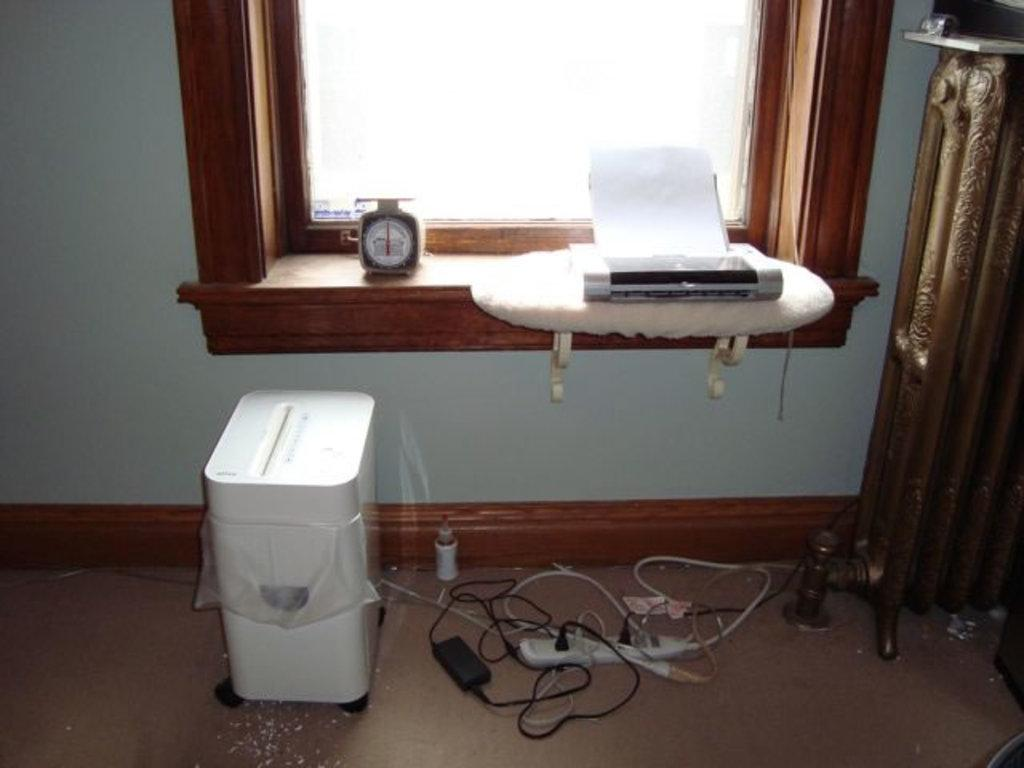What objects can be seen in the image that are related to technology? There are devices in the image that are related to technology. What material is present in the image that is typically used for writing or printing? There is paper in the image that is typically used for writing or printing. What connects the devices and other objects in the image? Cables are visible in the image that connect the devices and other objects. What is used to provide multiple power outlets in the image? There is an extension box in the image that provides multiple power outlets. What part of the image represents the ground or floor? The floor is visible in the image. What are the unspecified objects in the image? There are a few unspecified objects in the image, but we cannot describe them without more information. What can be seen in the background of the image that separates the interior from the exterior? There is a wall in the background of the image that separates the interior from the exterior. What can be seen in the background of the image that allows natural light to enter the room? There is a window in the background of the image that allows natural light to enter the room. What type of magic is being performed in the image? There is no magic being performed in the image; it features devices, paper, cables, an extension box, and a floor. What happens when the devices in the image burst? The devices in the image do not burst; they are functioning normally. 